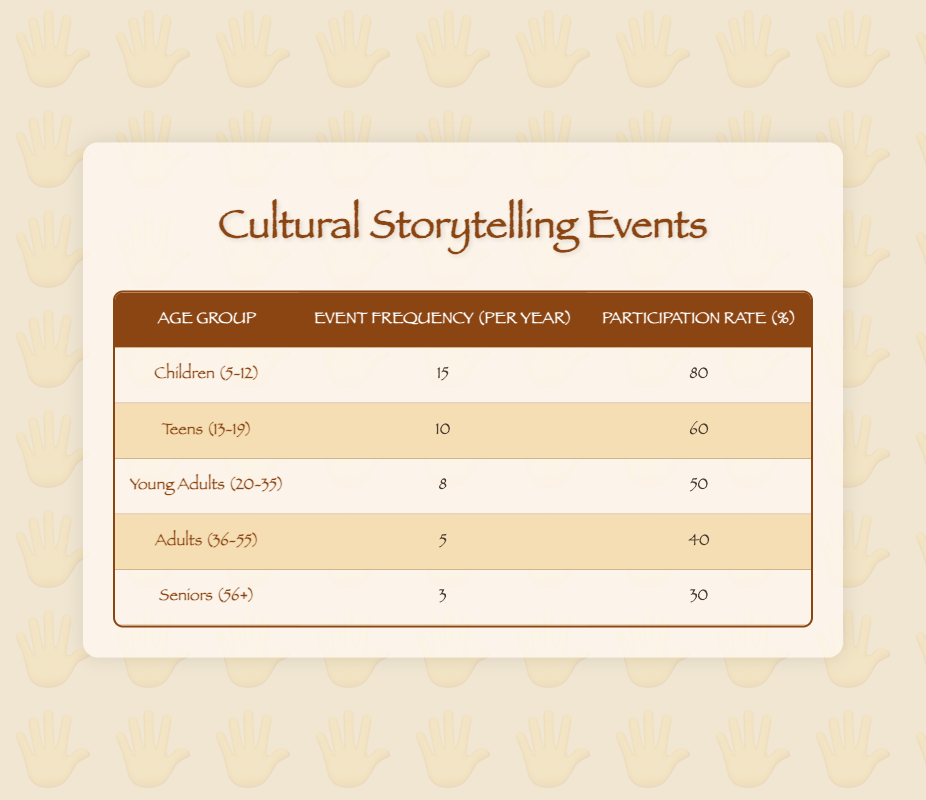What age group has the highest event frequency per year? The age group with the highest event frequency per year is Children (5-12), which has 15 events.
Answer: Children (5-12) What is the participation rate for Teens (13-19)? The participation rate for Teens (13-19) is 60%.
Answer: 60% How many events do Adults (36-55) participate in compared to Young Adults (20-35)? Adults (36-55) participate in 5 events per year while Young Adults (20-35) participate in 8 events. The difference is 8 - 5 = 3.
Answer: 3 fewer events What is the average event frequency for all age groups? The total event frequency is 15 + 10 + 8 + 5 + 3 = 41 events. There are 5 age groups, so the average is 41 / 5 = 8.2.
Answer: 8.2 events Is it true that Seniors (56+) have a higher participation rate than Adults (36-55)? No, it is false. Seniors (56+) have a participation rate of 30%, while Adults (36-55) have a participation rate of 40%.
Answer: No What is the total participation rate across all age groups? The total participation rate is calculated by adding each group’s participation rate: 80 + 60 + 50 + 40 + 30 = 260%.
Answer: 260% How does the event frequency of Young Adults (20-35) compare to the average event frequency? Young Adults (20-35) have an event frequency of 8, while the average is 8.2. This means they have 0.2 fewer events than the average.
Answer: 0.2 fewer events What age group shows the lowest frequency of cultural storytelling events? The age group with the lowest frequency of cultural storytelling events is Seniors (56+), with 3 events per year.
Answer: Seniors (56+) How does the participation rate of Children (5-12) compare to that of Seniors (56+)? Children (5-12) have a participation rate of 80%, while Seniors (56+) have 30%. The difference is 80 - 30 = 50%.
Answer: 50% higher Which age group has more events, and how many more compared to Teens (13-19)? Children (5-12) have 15 events, which is 5 more than Teens (13-19) who have 10 events. The difference is 15 - 10 = 5.
Answer: 5 more events 